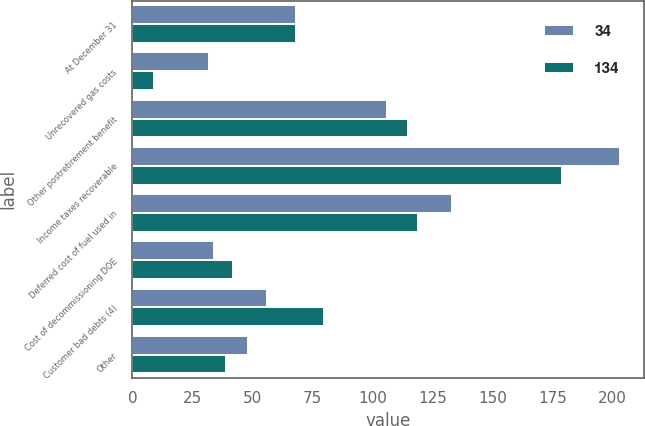<chart> <loc_0><loc_0><loc_500><loc_500><stacked_bar_chart><ecel><fcel>At December 31<fcel>Unrecovered gas costs<fcel>Other postretirement benefit<fcel>Income taxes recoverable<fcel>Deferred cost of fuel used in<fcel>Cost of decommissioning DOE<fcel>Customer bad debts (4)<fcel>Other<nl><fcel>34<fcel>68<fcel>32<fcel>106<fcel>203<fcel>133<fcel>34<fcel>56<fcel>48<nl><fcel>134<fcel>68<fcel>9<fcel>115<fcel>179<fcel>119<fcel>42<fcel>80<fcel>39<nl></chart> 